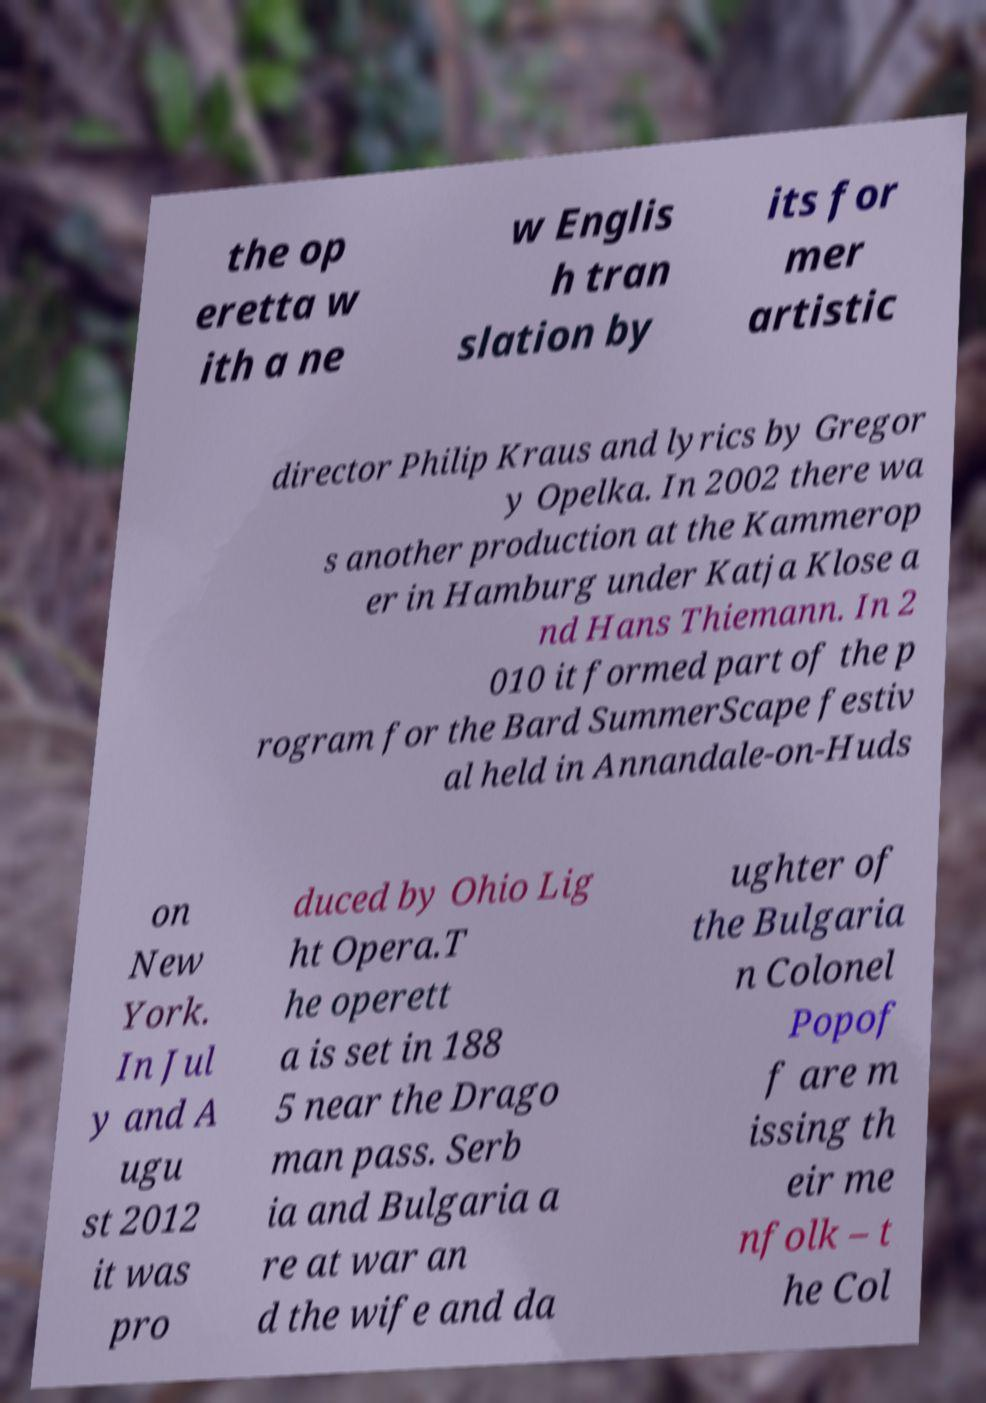There's text embedded in this image that I need extracted. Can you transcribe it verbatim? the op eretta w ith a ne w Englis h tran slation by its for mer artistic director Philip Kraus and lyrics by Gregor y Opelka. In 2002 there wa s another production at the Kammerop er in Hamburg under Katja Klose a nd Hans Thiemann. In 2 010 it formed part of the p rogram for the Bard SummerScape festiv al held in Annandale-on-Huds on New York. In Jul y and A ugu st 2012 it was pro duced by Ohio Lig ht Opera.T he operett a is set in 188 5 near the Drago man pass. Serb ia and Bulgaria a re at war an d the wife and da ughter of the Bulgaria n Colonel Popof f are m issing th eir me nfolk – t he Col 